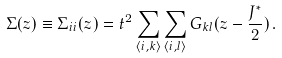<formula> <loc_0><loc_0><loc_500><loc_500>\Sigma ( z ) \equiv \Sigma _ { i i } ( z ) = t ^ { 2 } \sum _ { \langle i , k \rangle } \sum _ { \langle i , l \rangle } G _ { k l } ( z - \frac { J ^ { \ast } } { 2 } ) \, .</formula> 